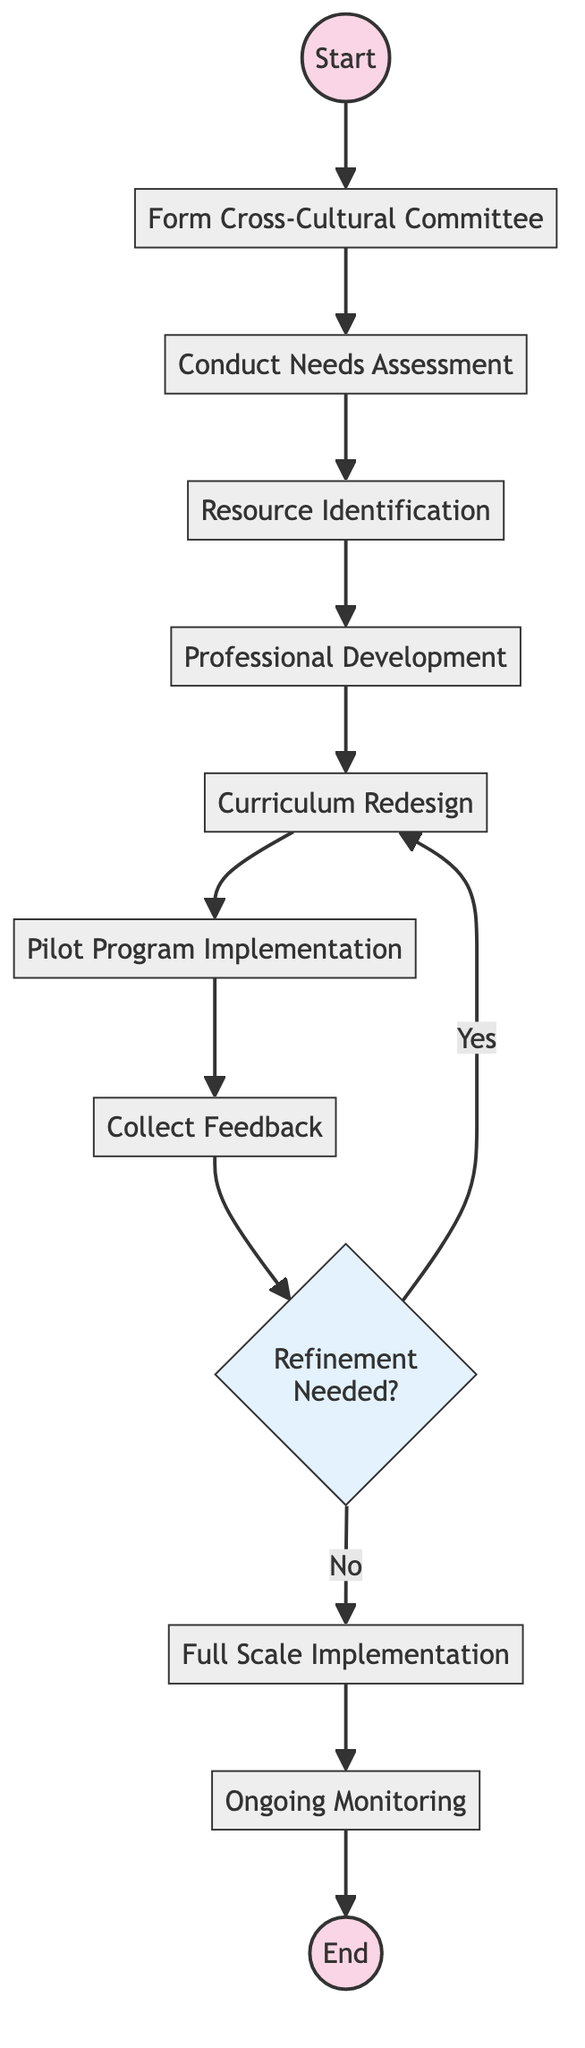What is the first activity in the diagram? The first activity listed in the diagram is "Form Cross-Cultural Committee," which is directly connected to the Start node.
Answer: Form Cross-Cultural Committee How many total activities are present in the diagram? The diagram presents a total of ten activities that are shown as separate nodes starting from the "Form Cross-Cultural Committee" to "Ongoing Monitoring," including the decision point.
Answer: 10 Which activity comes directly before the "Full Scale Implementation"? The activity that comes directly before "Full Scale Implementation" is "Refinement," as indicated by the direct arrow leading from "Refinement" to "Full Scale Implementation."
Answer: Refinement What is the decision point in the diagram? The decision point in the diagram is labeled "Refinement Needed?" which indicates that feedback must be evaluated to determine if further refinement of the curriculum is required.
Answer: Refinement Needed? What happens if the answer to the decision point is "Yes"? If the answer to the decision point "Refinement Needed?" is "Yes," the process loops back to "Professional Development" for further modifications and training.
Answer: Professional Development What is the outcome of the entire initiative as indicated in the diagram? The final outcome of the initiative is provided at the end of the diagram, where it states "Achieve Comprehensive Historical Perspectives Curriculum," summarizing the ultimate goal of the initiative.
Answer: Achieve Comprehensive Historical Perspectives Curriculum Which activity focus on preparing teachers for the new curriculum? The activity focusing on preparing teachers for the new curriculum is "Professional Development," which includes organizing training sessions for teachers.
Answer: Professional Development How is feedback collected after implementing the pilot program? Feedback is collected through the "Collect Feedback" activity, which indicates that input from students, teachers, and parents is gathered to assess the pilot program's effectiveness.
Answer: Collect Feedback What is the purpose of the "Needs Assessment" activity? The purpose of the "Conduct Needs Assessment" activity is to assess the current curriculum and identify gaps, specifically regarding non-Eurocentric historical content.
Answer: Assess current curriculum and identify gaps What occurs after feedback is collected? After feedback is collected, the process moves to the decision point regarding whether "Refinement" is needed, which influences whether to iterate back to "Professional Development" or proceed to "Full Scale Implementation."
Answer: Refinement Needed? 